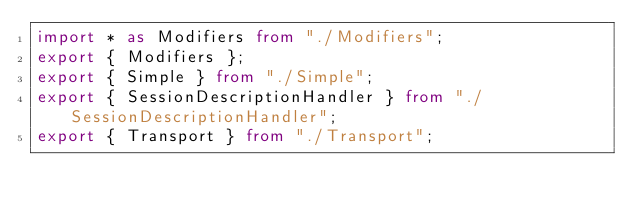<code> <loc_0><loc_0><loc_500><loc_500><_TypeScript_>import * as Modifiers from "./Modifiers";
export { Modifiers };
export { Simple } from "./Simple";
export { SessionDescriptionHandler } from "./SessionDescriptionHandler";
export { Transport } from "./Transport";
</code> 